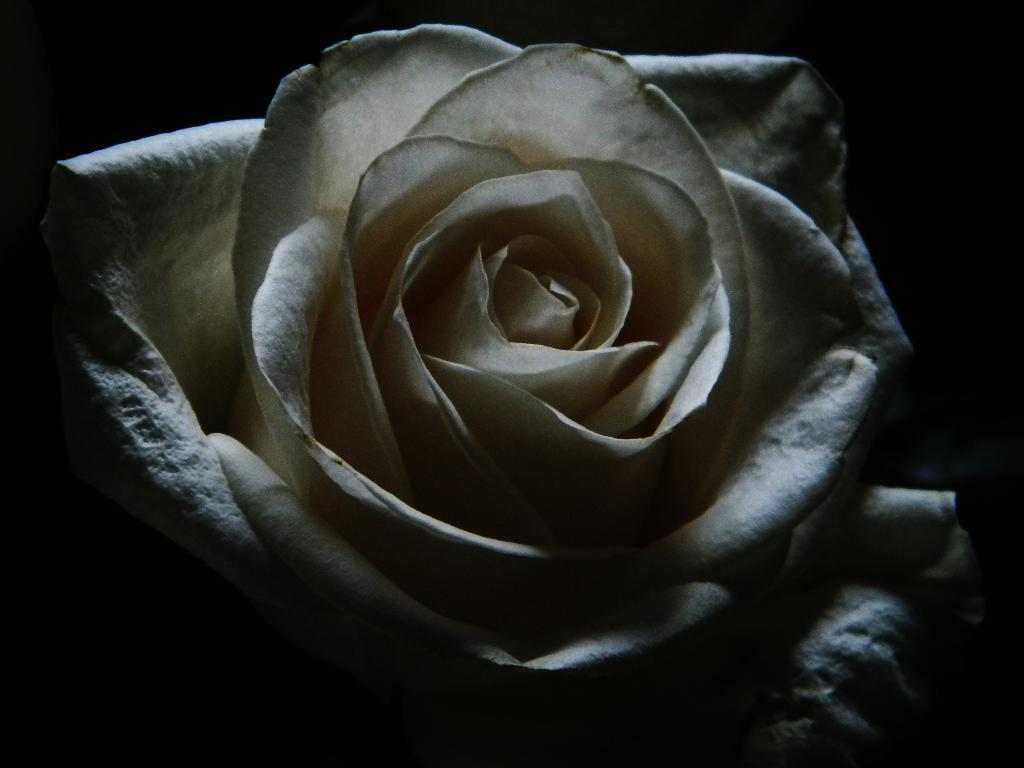What type of flower is in the image? There is a white rose in the image. What can be observed about the background of the image? The background of the image is dark. What type of insect is crawling on the health border in the image? There is no insect or health border present in the image; it only features a white rose with a dark background. 